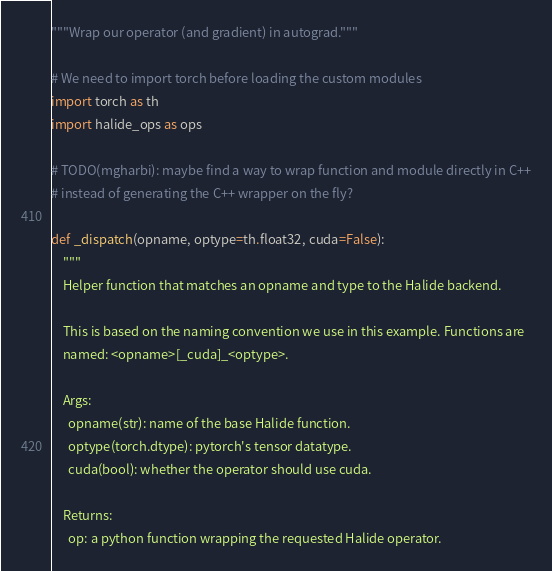Convert code to text. <code><loc_0><loc_0><loc_500><loc_500><_Python_>"""Wrap our operator (and gradient) in autograd."""

# We need to import torch before loading the custom modules
import torch as th
import halide_ops as ops

# TODO(mgharbi): maybe find a way to wrap function and module directly in C++
# instead of generating the C++ wrapper on the fly?

def _dispatch(opname, optype=th.float32, cuda=False):
    """
    Helper function that matches an opname and type to the Halide backend.

    This is based on the naming convention we use in this example. Functions are
    named: <opname>[_cuda]_<optype>.

    Args:
      opname(str): name of the base Halide function.
      optype(torch.dtype): pytorch's tensor datatype.
      cuda(bool): whether the operator should use cuda.

    Returns:
      op: a python function wrapping the requested Halide operator.</code> 